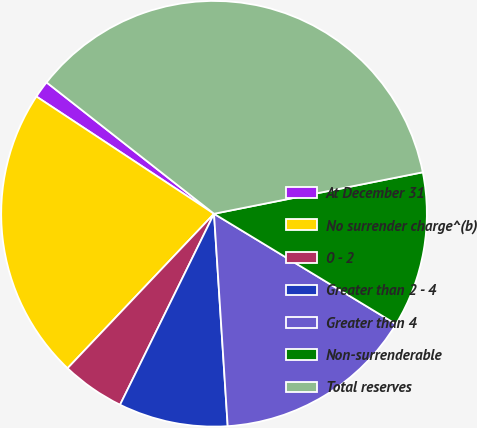Convert chart. <chart><loc_0><loc_0><loc_500><loc_500><pie_chart><fcel>At December 31<fcel>No surrender charge^(b)<fcel>0 - 2<fcel>Greater than 2 - 4<fcel>Greater than 4<fcel>Non-surrenderable<fcel>Total reserves<nl><fcel>1.3%<fcel>22.21%<fcel>4.8%<fcel>8.3%<fcel>15.3%<fcel>11.8%<fcel>36.29%<nl></chart> 